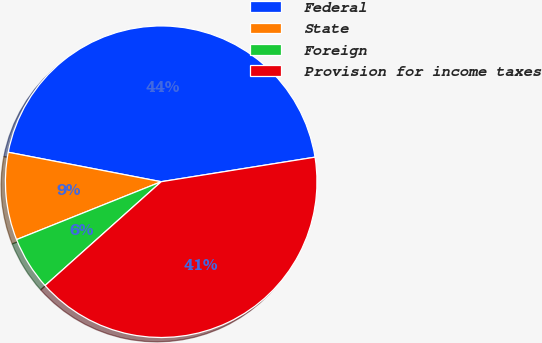Convert chart to OTSL. <chart><loc_0><loc_0><loc_500><loc_500><pie_chart><fcel>Federal<fcel>State<fcel>Foreign<fcel>Provision for income taxes<nl><fcel>44.45%<fcel>9.09%<fcel>5.55%<fcel>40.91%<nl></chart> 